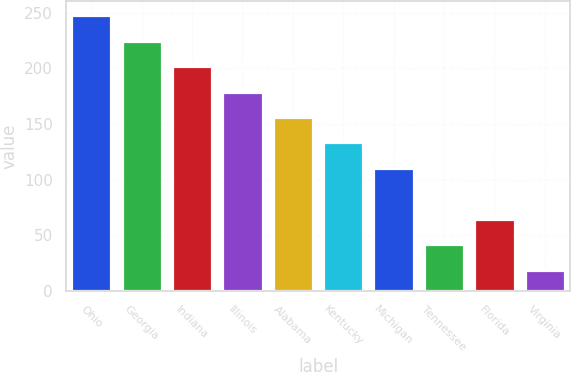<chart> <loc_0><loc_0><loc_500><loc_500><bar_chart><fcel>Ohio<fcel>Georgia<fcel>Indiana<fcel>Illinois<fcel>Alabama<fcel>Kentucky<fcel>Michigan<fcel>Tennessee<fcel>Florida<fcel>Virginia<nl><fcel>248<fcel>225.1<fcel>202.2<fcel>179.3<fcel>156.4<fcel>133.5<fcel>110.6<fcel>41.9<fcel>64.8<fcel>19<nl></chart> 